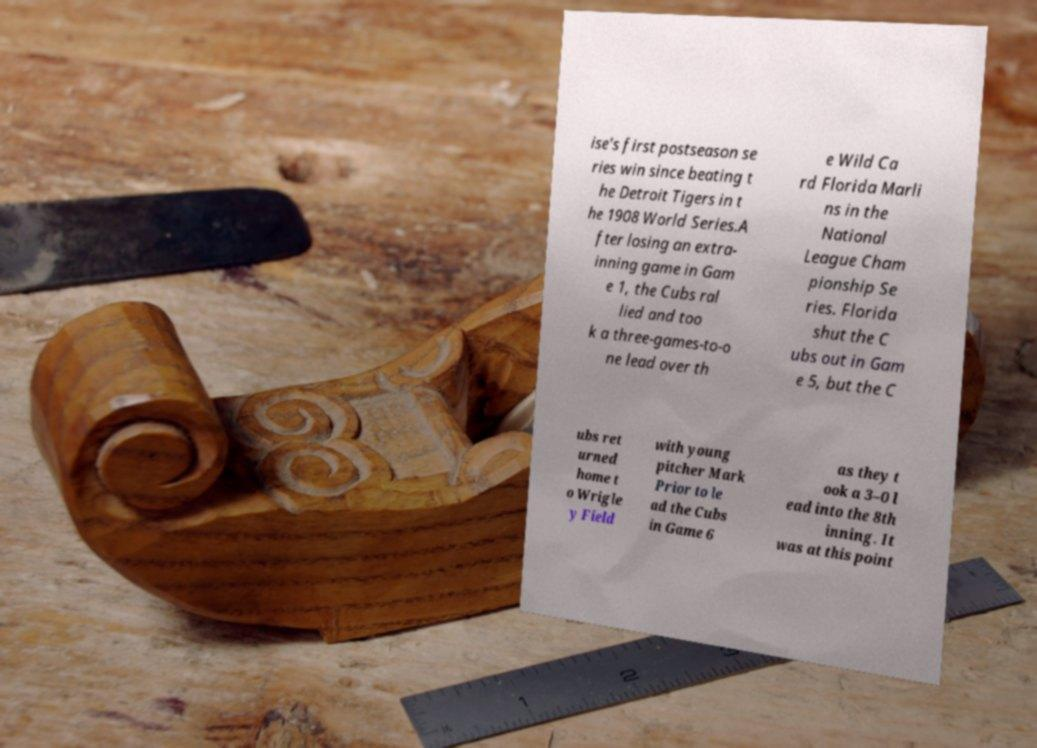Could you extract and type out the text from this image? ise's first postseason se ries win since beating t he Detroit Tigers in t he 1908 World Series.A fter losing an extra- inning game in Gam e 1, the Cubs ral lied and too k a three-games-to-o ne lead over th e Wild Ca rd Florida Marli ns in the National League Cham pionship Se ries. Florida shut the C ubs out in Gam e 5, but the C ubs ret urned home t o Wrigle y Field with young pitcher Mark Prior to le ad the Cubs in Game 6 as they t ook a 3–0 l ead into the 8th inning. It was at this point 